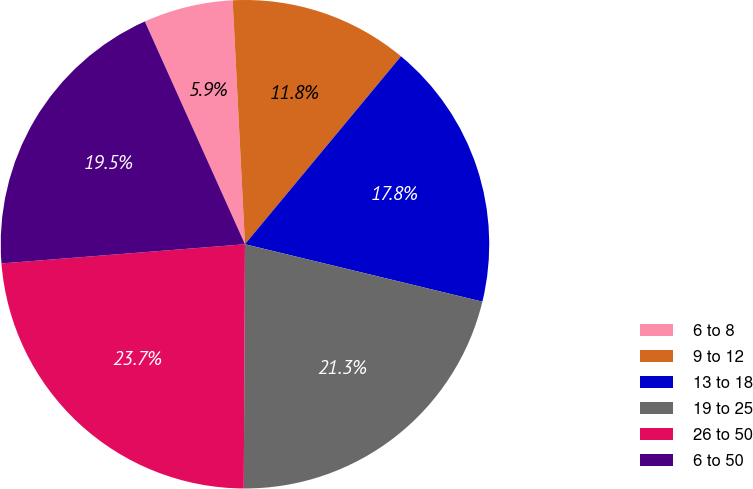Convert chart. <chart><loc_0><loc_0><loc_500><loc_500><pie_chart><fcel>6 to 8<fcel>9 to 12<fcel>13 to 18<fcel>19 to 25<fcel>26 to 50<fcel>6 to 50<nl><fcel>5.92%<fcel>11.83%<fcel>17.75%<fcel>21.3%<fcel>23.67%<fcel>19.53%<nl></chart> 